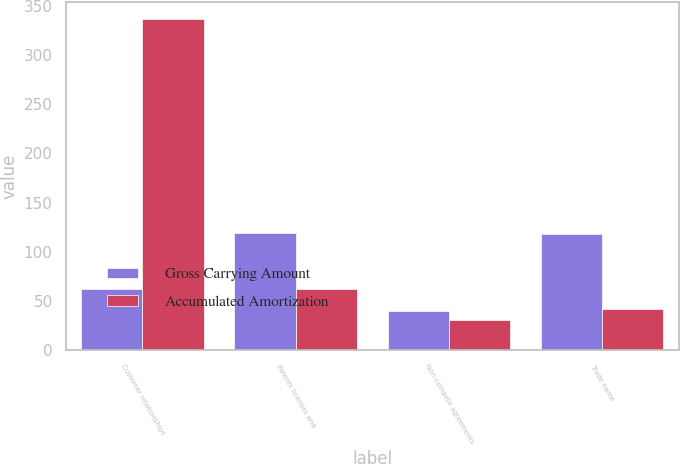Convert chart. <chart><loc_0><loc_0><loc_500><loc_500><stacked_bar_chart><ecel><fcel>Customer relationships<fcel>Patents licenses and<fcel>Non-compete agreements<fcel>Trade name<nl><fcel>Gross Carrying Amount<fcel>62.4<fcel>119.2<fcel>39.4<fcel>117.7<nl><fcel>Accumulated Amortization<fcel>337.1<fcel>62.4<fcel>30.7<fcel>41.8<nl></chart> 